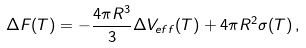<formula> <loc_0><loc_0><loc_500><loc_500>\Delta F ( T ) = - \frac { 4 \pi R ^ { 3 } } { 3 } \Delta V _ { e f f } ( T ) + 4 \pi R ^ { 2 } \sigma ( T ) \, ,</formula> 